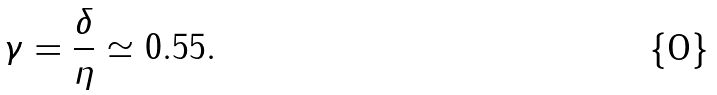Convert formula to latex. <formula><loc_0><loc_0><loc_500><loc_500>\gamma = \frac { \delta } { \eta } \simeq 0 . 5 5 .</formula> 